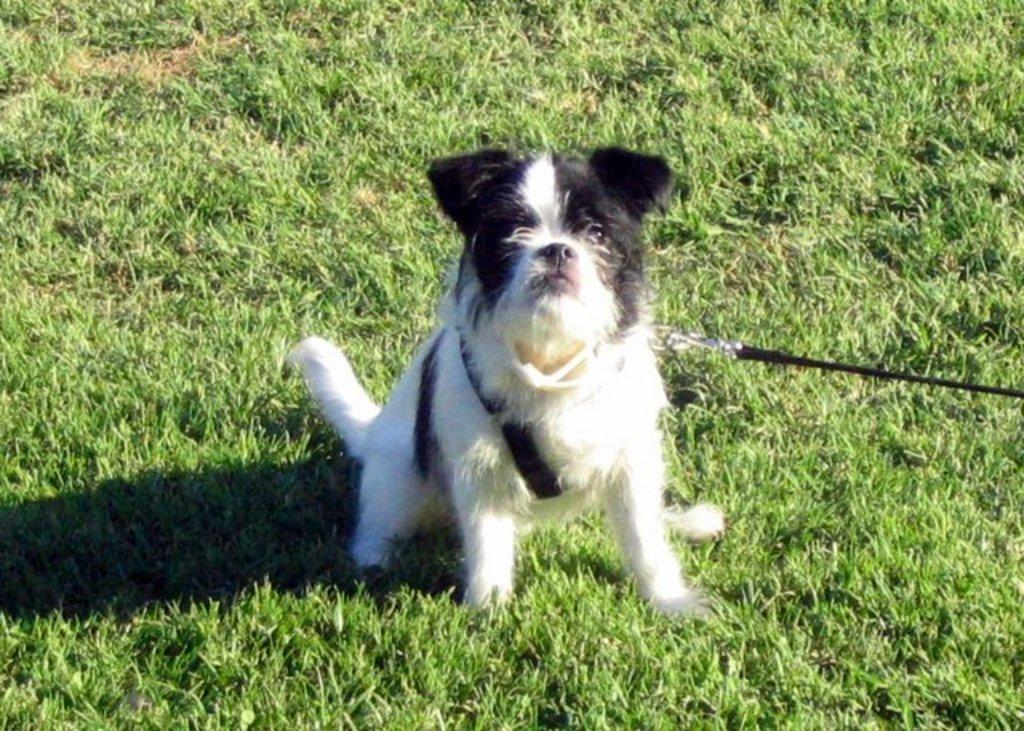What type of animal is present in the image? There is a dog in the image. What is the dog wearing in the image? The dog is wearing a belt in the image. Where is the dog sitting in the image? The dog is sitting on the grass in the image. What type of mint can be seen growing on the dog's fur in the image? There is no mint present on the dog's fur in the image. 